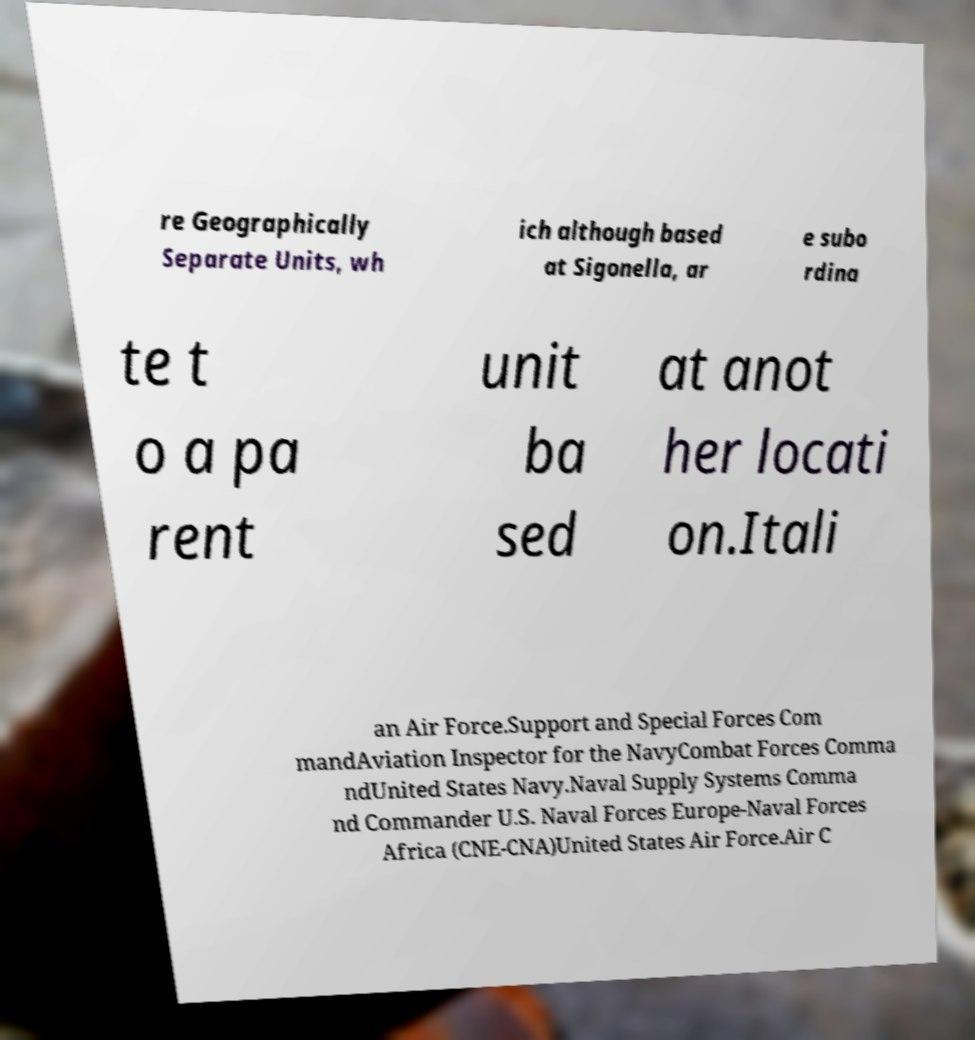Please read and relay the text visible in this image. What does it say? re Geographically Separate Units, wh ich although based at Sigonella, ar e subo rdina te t o a pa rent unit ba sed at anot her locati on.Itali an Air Force.Support and Special Forces Com mandAviation Inspector for the NavyCombat Forces Comma ndUnited States Navy.Naval Supply Systems Comma nd Commander U.S. Naval Forces Europe-Naval Forces Africa (CNE-CNA)United States Air Force.Air C 